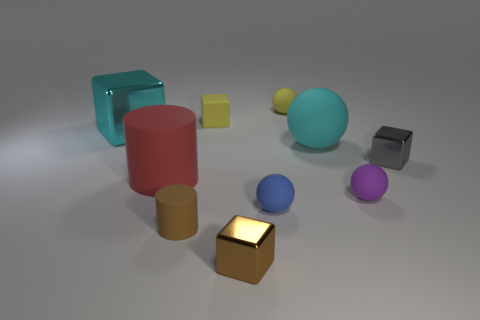There is another tiny thing that is the same material as the small gray thing; what shape is it?
Ensure brevity in your answer.  Cube. What size is the cyan metallic object?
Ensure brevity in your answer.  Large. Do the brown rubber cylinder and the yellow matte cube have the same size?
Your answer should be compact. Yes. How many things are either blocks that are right of the small cylinder or rubber balls behind the gray metallic object?
Your answer should be compact. 5. How many balls are in front of the yellow object that is behind the yellow object in front of the tiny yellow matte ball?
Ensure brevity in your answer.  3. How big is the object on the left side of the red matte object?
Offer a very short reply. Large. How many spheres are the same size as the yellow matte block?
Offer a terse response. 3. There is a cyan matte thing; is it the same size as the shiny cube that is behind the big matte ball?
Keep it short and to the point. Yes. How many things are tiny yellow matte objects or red metallic things?
Provide a succinct answer. 2. How many balls have the same color as the large metallic thing?
Your response must be concise. 1. 